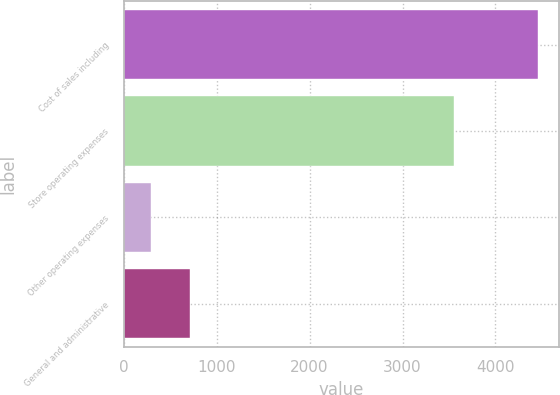Convert chart to OTSL. <chart><loc_0><loc_0><loc_500><loc_500><bar_chart><fcel>Cost of sales including<fcel>Store operating expenses<fcel>Other operating expenses<fcel>General and administrative<nl><fcel>4458.6<fcel>3551.4<fcel>293.2<fcel>709.74<nl></chart> 